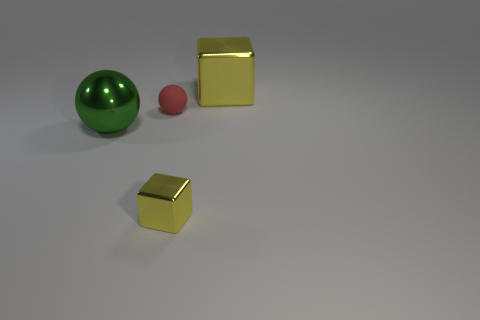What is the cube behind the metal block that is in front of the big yellow metallic cube made of?
Offer a very short reply. Metal. How many other things are there of the same shape as the big green shiny object?
Give a very brief answer. 1. There is a big object that is behind the green metal ball; does it have the same shape as the yellow metallic object that is in front of the tiny red rubber ball?
Your answer should be very brief. Yes. Is there anything else that has the same material as the tiny red sphere?
Provide a succinct answer. No. What material is the red sphere?
Provide a short and direct response. Rubber. There is a ball that is behind the big sphere; what is its material?
Provide a short and direct response. Rubber. Is there any other thing of the same color as the tiny metal thing?
Give a very brief answer. Yes. There is another yellow block that is made of the same material as the large yellow block; what is its size?
Keep it short and to the point. Small. How many small things are green metal spheres or yellow balls?
Your answer should be very brief. 0. There is a yellow object left of the large shiny thing that is behind the big thing that is on the left side of the large block; what is its size?
Your answer should be very brief. Small. 